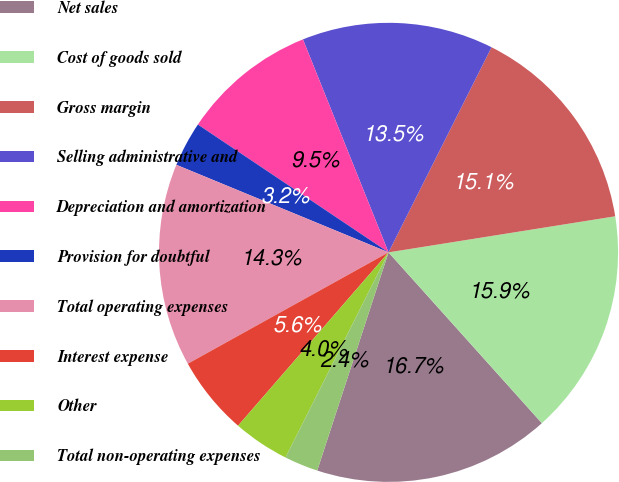Convert chart to OTSL. <chart><loc_0><loc_0><loc_500><loc_500><pie_chart><fcel>Net sales<fcel>Cost of goods sold<fcel>Gross margin<fcel>Selling administrative and<fcel>Depreciation and amortization<fcel>Provision for doubtful<fcel>Total operating expenses<fcel>Interest expense<fcel>Other<fcel>Total non-operating expenses<nl><fcel>16.67%<fcel>15.87%<fcel>15.08%<fcel>13.49%<fcel>9.52%<fcel>3.17%<fcel>14.29%<fcel>5.56%<fcel>3.97%<fcel>2.38%<nl></chart> 